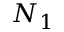Convert formula to latex. <formula><loc_0><loc_0><loc_500><loc_500>N _ { 1 }</formula> 